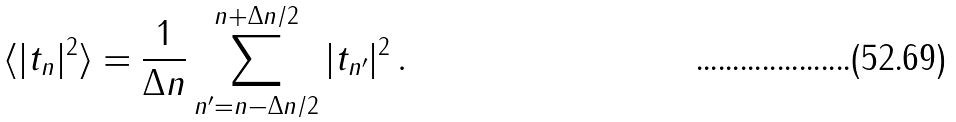Convert formula to latex. <formula><loc_0><loc_0><loc_500><loc_500>\langle | t _ { n } | ^ { 2 } \rangle = \frac { 1 } { \Delta n } \sum _ { n ^ { \prime } = n - \Delta n / 2 } ^ { n + \Delta n / 2 } | t _ { n ^ { \prime } } | ^ { 2 } \, .</formula> 